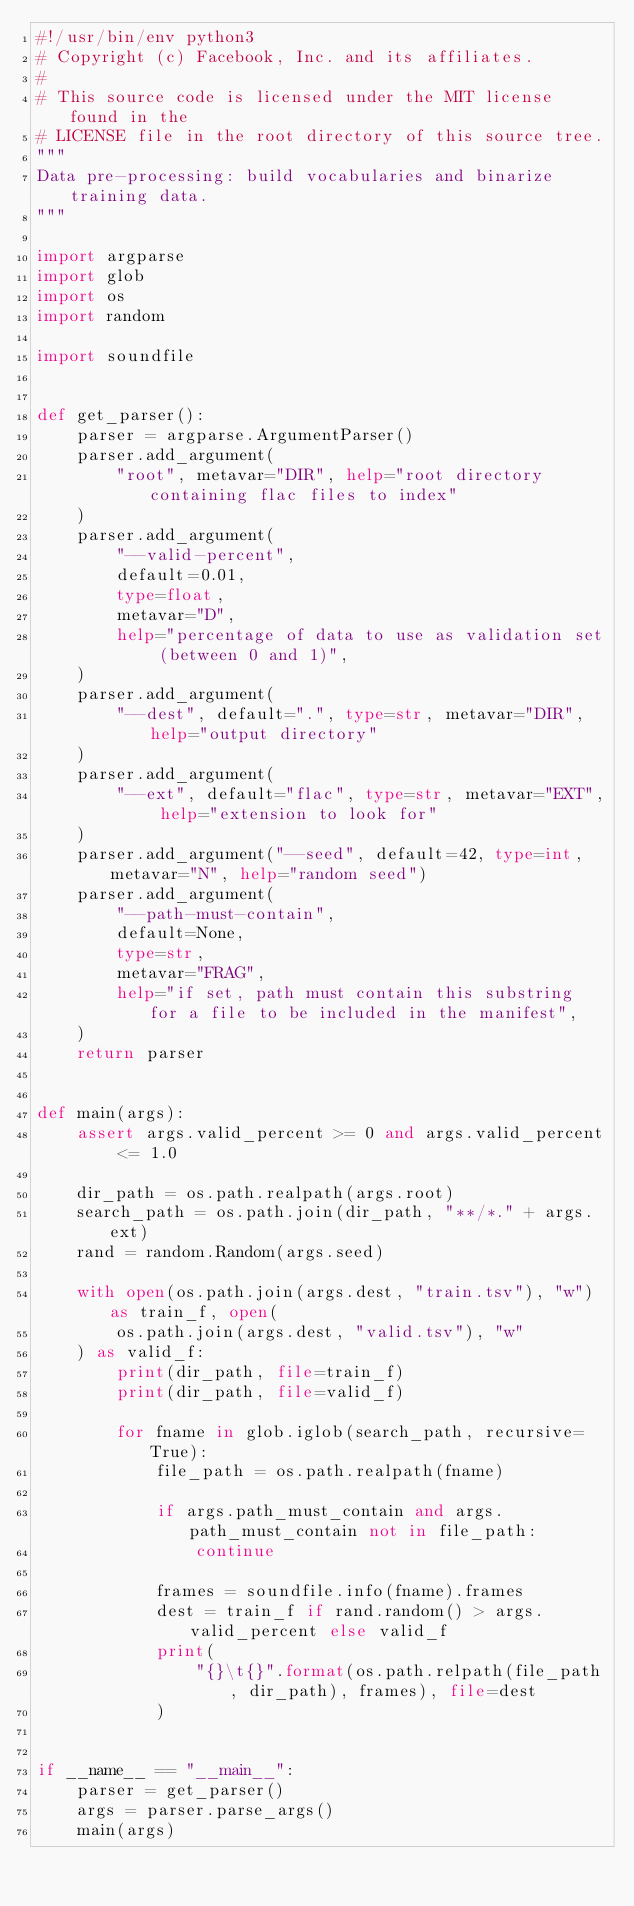<code> <loc_0><loc_0><loc_500><loc_500><_Python_>#!/usr/bin/env python3
# Copyright (c) Facebook, Inc. and its affiliates.
#
# This source code is licensed under the MIT license found in the
# LICENSE file in the root directory of this source tree.
"""
Data pre-processing: build vocabularies and binarize training data.
"""

import argparse
import glob
import os
import random

import soundfile


def get_parser():
    parser = argparse.ArgumentParser()
    parser.add_argument(
        "root", metavar="DIR", help="root directory containing flac files to index"
    )
    parser.add_argument(
        "--valid-percent",
        default=0.01,
        type=float,
        metavar="D",
        help="percentage of data to use as validation set (between 0 and 1)",
    )
    parser.add_argument(
        "--dest", default=".", type=str, metavar="DIR", help="output directory"
    )
    parser.add_argument(
        "--ext", default="flac", type=str, metavar="EXT", help="extension to look for"
    )
    parser.add_argument("--seed", default=42, type=int, metavar="N", help="random seed")
    parser.add_argument(
        "--path-must-contain",
        default=None,
        type=str,
        metavar="FRAG",
        help="if set, path must contain this substring for a file to be included in the manifest",
    )
    return parser


def main(args):
    assert args.valid_percent >= 0 and args.valid_percent <= 1.0

    dir_path = os.path.realpath(args.root)
    search_path = os.path.join(dir_path, "**/*." + args.ext)
    rand = random.Random(args.seed)

    with open(os.path.join(args.dest, "train.tsv"), "w") as train_f, open(
        os.path.join(args.dest, "valid.tsv"), "w"
    ) as valid_f:
        print(dir_path, file=train_f)
        print(dir_path, file=valid_f)

        for fname in glob.iglob(search_path, recursive=True):
            file_path = os.path.realpath(fname)

            if args.path_must_contain and args.path_must_contain not in file_path:
                continue

            frames = soundfile.info(fname).frames
            dest = train_f if rand.random() > args.valid_percent else valid_f
            print(
                "{}\t{}".format(os.path.relpath(file_path, dir_path), frames), file=dest
            )


if __name__ == "__main__":
    parser = get_parser()
    args = parser.parse_args()
    main(args)
</code> 